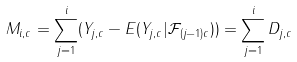<formula> <loc_0><loc_0><loc_500><loc_500>M _ { i , c } = \sum _ { j = 1 } ^ { i } ( Y _ { j , c } - E ( Y _ { j , c } | \mathcal { F } _ { ( j - 1 ) c } ) ) = \sum _ { j = 1 } ^ { i } D _ { j , c } \,</formula> 